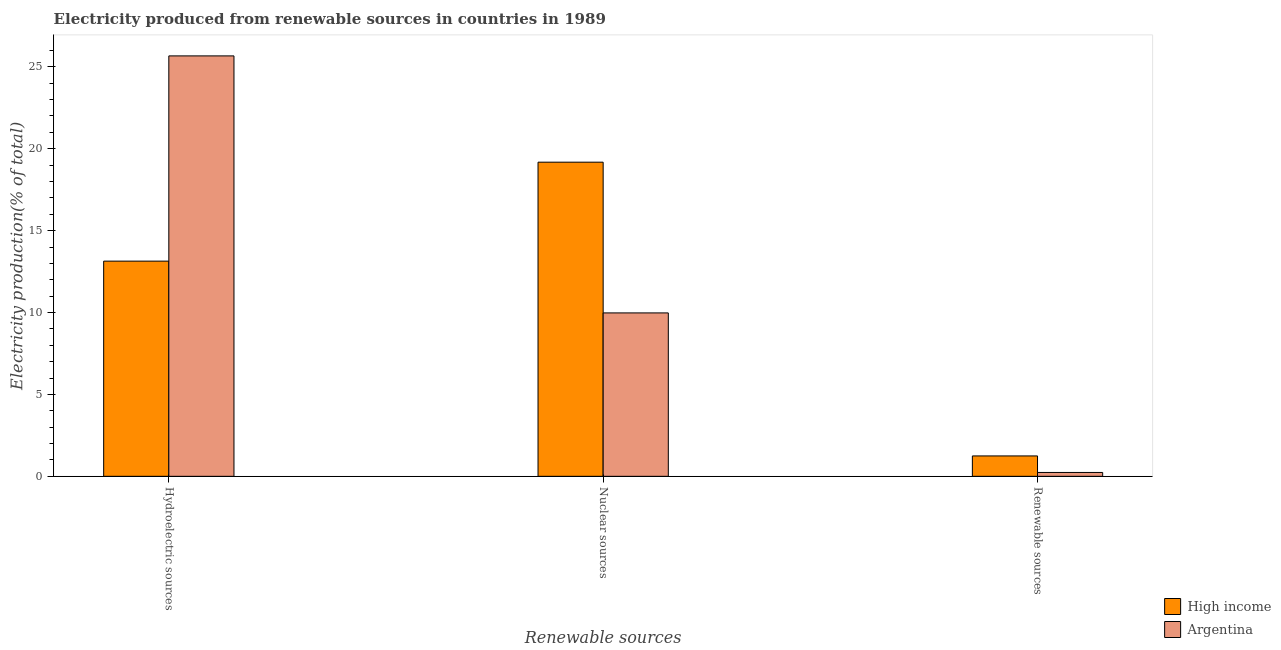Are the number of bars per tick equal to the number of legend labels?
Your answer should be compact. Yes. How many bars are there on the 3rd tick from the right?
Your response must be concise. 2. What is the label of the 3rd group of bars from the left?
Your answer should be very brief. Renewable sources. What is the percentage of electricity produced by hydroelectric sources in Argentina?
Your answer should be very brief. 25.67. Across all countries, what is the maximum percentage of electricity produced by hydroelectric sources?
Your answer should be very brief. 25.67. Across all countries, what is the minimum percentage of electricity produced by nuclear sources?
Provide a short and direct response. 9.98. In which country was the percentage of electricity produced by nuclear sources maximum?
Make the answer very short. High income. What is the total percentage of electricity produced by hydroelectric sources in the graph?
Make the answer very short. 38.8. What is the difference between the percentage of electricity produced by renewable sources in High income and that in Argentina?
Provide a short and direct response. 1.01. What is the difference between the percentage of electricity produced by renewable sources in Argentina and the percentage of electricity produced by nuclear sources in High income?
Your response must be concise. -18.94. What is the average percentage of electricity produced by hydroelectric sources per country?
Ensure brevity in your answer.  19.4. What is the difference between the percentage of electricity produced by renewable sources and percentage of electricity produced by nuclear sources in High income?
Your response must be concise. -17.93. In how many countries, is the percentage of electricity produced by nuclear sources greater than 25 %?
Make the answer very short. 0. What is the ratio of the percentage of electricity produced by renewable sources in Argentina to that in High income?
Provide a succinct answer. 0.19. Is the percentage of electricity produced by nuclear sources in Argentina less than that in High income?
Your answer should be compact. Yes. What is the difference between the highest and the second highest percentage of electricity produced by nuclear sources?
Offer a terse response. 9.2. What is the difference between the highest and the lowest percentage of electricity produced by hydroelectric sources?
Provide a succinct answer. 12.53. What does the 1st bar from the left in Nuclear sources represents?
Keep it short and to the point. High income. What does the 1st bar from the right in Nuclear sources represents?
Offer a terse response. Argentina. Is it the case that in every country, the sum of the percentage of electricity produced by hydroelectric sources and percentage of electricity produced by nuclear sources is greater than the percentage of electricity produced by renewable sources?
Ensure brevity in your answer.  Yes. Are the values on the major ticks of Y-axis written in scientific E-notation?
Provide a succinct answer. No. Where does the legend appear in the graph?
Your response must be concise. Bottom right. How many legend labels are there?
Offer a very short reply. 2. How are the legend labels stacked?
Provide a succinct answer. Vertical. What is the title of the graph?
Make the answer very short. Electricity produced from renewable sources in countries in 1989. Does "Australia" appear as one of the legend labels in the graph?
Give a very brief answer. No. What is the label or title of the X-axis?
Offer a very short reply. Renewable sources. What is the Electricity production(% of total) in High income in Hydroelectric sources?
Ensure brevity in your answer.  13.14. What is the Electricity production(% of total) of Argentina in Hydroelectric sources?
Keep it short and to the point. 25.67. What is the Electricity production(% of total) of High income in Nuclear sources?
Give a very brief answer. 19.18. What is the Electricity production(% of total) in Argentina in Nuclear sources?
Your answer should be very brief. 9.98. What is the Electricity production(% of total) of High income in Renewable sources?
Give a very brief answer. 1.24. What is the Electricity production(% of total) of Argentina in Renewable sources?
Keep it short and to the point. 0.24. Across all Renewable sources, what is the maximum Electricity production(% of total) of High income?
Offer a terse response. 19.18. Across all Renewable sources, what is the maximum Electricity production(% of total) of Argentina?
Offer a very short reply. 25.67. Across all Renewable sources, what is the minimum Electricity production(% of total) in High income?
Your response must be concise. 1.24. Across all Renewable sources, what is the minimum Electricity production(% of total) of Argentina?
Keep it short and to the point. 0.24. What is the total Electricity production(% of total) in High income in the graph?
Provide a succinct answer. 33.56. What is the total Electricity production(% of total) of Argentina in the graph?
Keep it short and to the point. 35.88. What is the difference between the Electricity production(% of total) in High income in Hydroelectric sources and that in Nuclear sources?
Provide a succinct answer. -6.04. What is the difference between the Electricity production(% of total) in Argentina in Hydroelectric sources and that in Nuclear sources?
Ensure brevity in your answer.  15.69. What is the difference between the Electricity production(% of total) in High income in Hydroelectric sources and that in Renewable sources?
Offer a terse response. 11.89. What is the difference between the Electricity production(% of total) in Argentina in Hydroelectric sources and that in Renewable sources?
Provide a short and direct response. 25.43. What is the difference between the Electricity production(% of total) of High income in Nuclear sources and that in Renewable sources?
Provide a succinct answer. 17.93. What is the difference between the Electricity production(% of total) in Argentina in Nuclear sources and that in Renewable sources?
Your answer should be very brief. 9.74. What is the difference between the Electricity production(% of total) in High income in Hydroelectric sources and the Electricity production(% of total) in Argentina in Nuclear sources?
Your response must be concise. 3.16. What is the difference between the Electricity production(% of total) of High income in Hydroelectric sources and the Electricity production(% of total) of Argentina in Renewable sources?
Offer a terse response. 12.9. What is the difference between the Electricity production(% of total) in High income in Nuclear sources and the Electricity production(% of total) in Argentina in Renewable sources?
Make the answer very short. 18.94. What is the average Electricity production(% of total) in High income per Renewable sources?
Your answer should be very brief. 11.19. What is the average Electricity production(% of total) in Argentina per Renewable sources?
Provide a short and direct response. 11.96. What is the difference between the Electricity production(% of total) in High income and Electricity production(% of total) in Argentina in Hydroelectric sources?
Make the answer very short. -12.53. What is the difference between the Electricity production(% of total) in High income and Electricity production(% of total) in Argentina in Nuclear sources?
Provide a succinct answer. 9.2. What is the difference between the Electricity production(% of total) of High income and Electricity production(% of total) of Argentina in Renewable sources?
Make the answer very short. 1.01. What is the ratio of the Electricity production(% of total) of High income in Hydroelectric sources to that in Nuclear sources?
Ensure brevity in your answer.  0.69. What is the ratio of the Electricity production(% of total) of Argentina in Hydroelectric sources to that in Nuclear sources?
Your answer should be very brief. 2.57. What is the ratio of the Electricity production(% of total) in High income in Hydroelectric sources to that in Renewable sources?
Offer a very short reply. 10.55. What is the ratio of the Electricity production(% of total) in Argentina in Hydroelectric sources to that in Renewable sources?
Ensure brevity in your answer.  108.95. What is the ratio of the Electricity production(% of total) in High income in Nuclear sources to that in Renewable sources?
Your answer should be compact. 15.41. What is the ratio of the Electricity production(% of total) of Argentina in Nuclear sources to that in Renewable sources?
Your answer should be very brief. 42.34. What is the difference between the highest and the second highest Electricity production(% of total) in High income?
Offer a terse response. 6.04. What is the difference between the highest and the second highest Electricity production(% of total) in Argentina?
Keep it short and to the point. 15.69. What is the difference between the highest and the lowest Electricity production(% of total) in High income?
Provide a short and direct response. 17.93. What is the difference between the highest and the lowest Electricity production(% of total) of Argentina?
Your answer should be very brief. 25.43. 